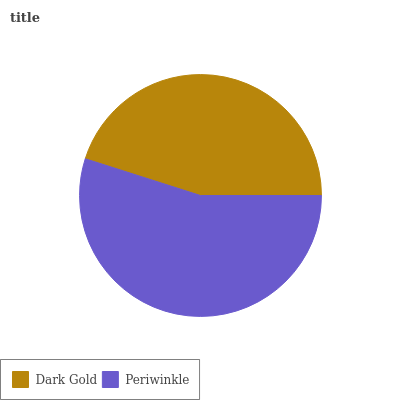Is Dark Gold the minimum?
Answer yes or no. Yes. Is Periwinkle the maximum?
Answer yes or no. Yes. Is Periwinkle the minimum?
Answer yes or no. No. Is Periwinkle greater than Dark Gold?
Answer yes or no. Yes. Is Dark Gold less than Periwinkle?
Answer yes or no. Yes. Is Dark Gold greater than Periwinkle?
Answer yes or no. No. Is Periwinkle less than Dark Gold?
Answer yes or no. No. Is Periwinkle the high median?
Answer yes or no. Yes. Is Dark Gold the low median?
Answer yes or no. Yes. Is Dark Gold the high median?
Answer yes or no. No. Is Periwinkle the low median?
Answer yes or no. No. 